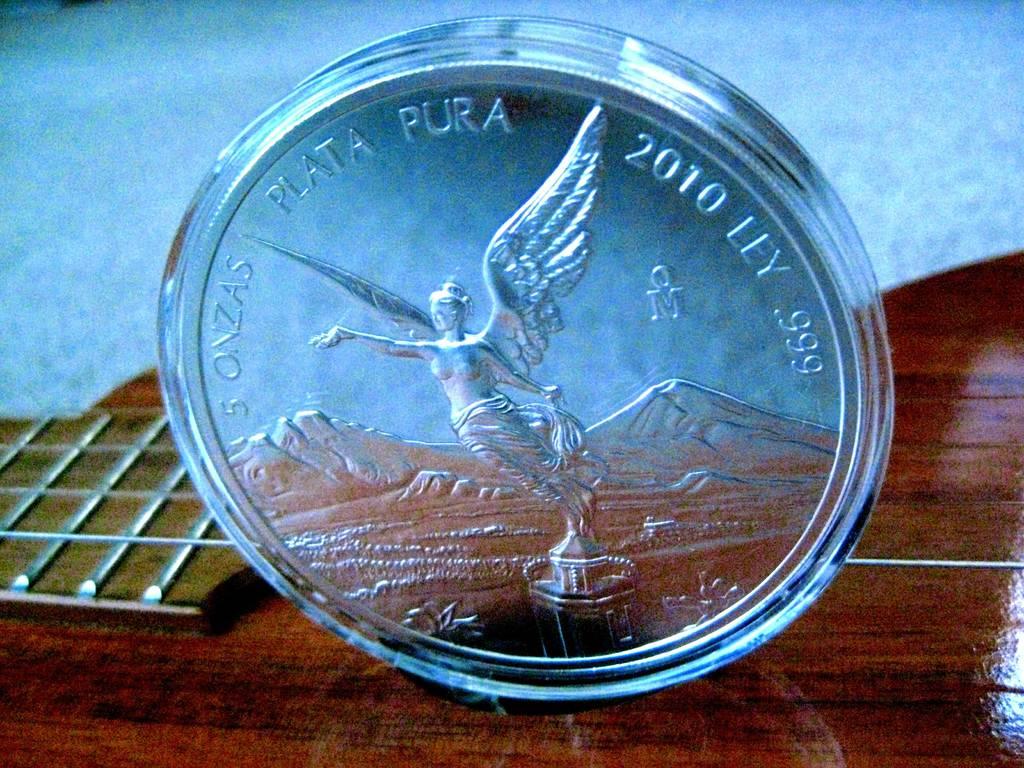What is the year stamp of the coin?
Your answer should be very brief. 2010. What name is wrote by the year?
Make the answer very short. Ley. 